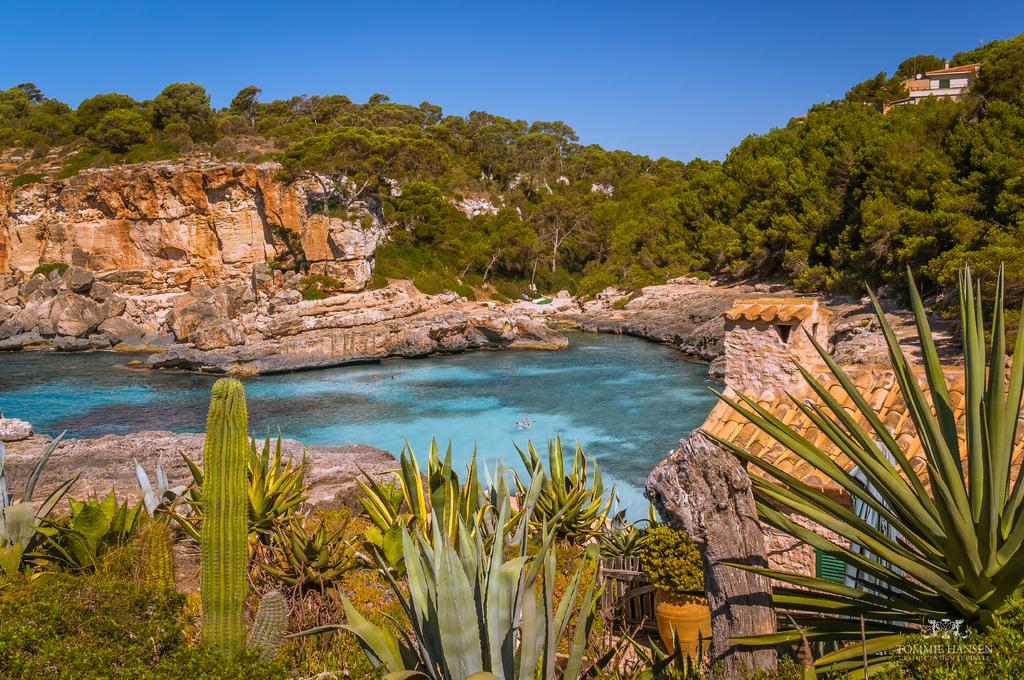What type of water body can be seen in the image? There is a pond in the image. What type of natural elements are present in the image? Stones, rocks, trees, plants, and the sky are visible in the image. What type of structures are present in the image? Buildings and sheds are present in the image. What type of lettuce is growing in the image? There is no lettuce present in the image; it features a pond, stones, rocks, trees, plants, buildings, and sheds. What type of government is depicted in the image? There is no depiction of a government in the image; it focuses on natural elements and structures. 